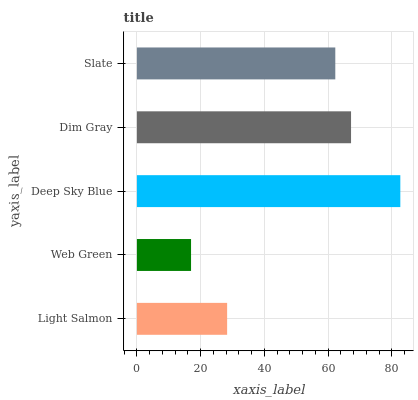Is Web Green the minimum?
Answer yes or no. Yes. Is Deep Sky Blue the maximum?
Answer yes or no. Yes. Is Deep Sky Blue the minimum?
Answer yes or no. No. Is Web Green the maximum?
Answer yes or no. No. Is Deep Sky Blue greater than Web Green?
Answer yes or no. Yes. Is Web Green less than Deep Sky Blue?
Answer yes or no. Yes. Is Web Green greater than Deep Sky Blue?
Answer yes or no. No. Is Deep Sky Blue less than Web Green?
Answer yes or no. No. Is Slate the high median?
Answer yes or no. Yes. Is Slate the low median?
Answer yes or no. Yes. Is Deep Sky Blue the high median?
Answer yes or no. No. Is Light Salmon the low median?
Answer yes or no. No. 